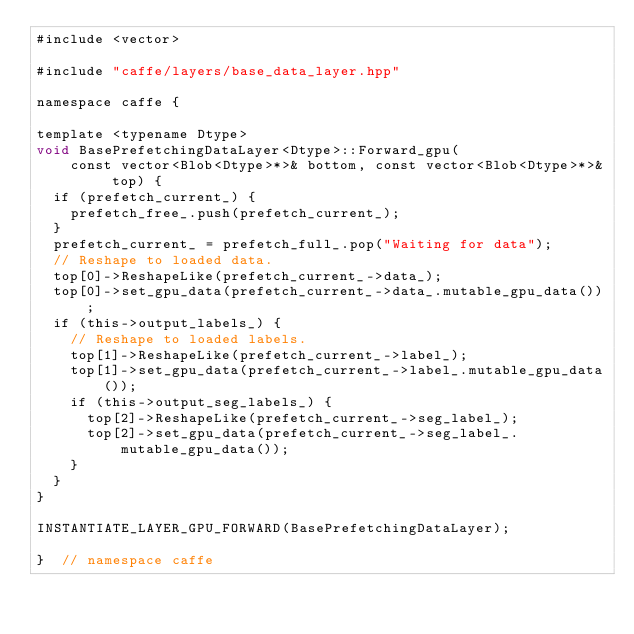<code> <loc_0><loc_0><loc_500><loc_500><_Cuda_>#include <vector>

#include "caffe/layers/base_data_layer.hpp"

namespace caffe {

template <typename Dtype>
void BasePrefetchingDataLayer<Dtype>::Forward_gpu(
    const vector<Blob<Dtype>*>& bottom, const vector<Blob<Dtype>*>& top) {
  if (prefetch_current_) {
    prefetch_free_.push(prefetch_current_);
  }
  prefetch_current_ = prefetch_full_.pop("Waiting for data");
  // Reshape to loaded data.
  top[0]->ReshapeLike(prefetch_current_->data_);
  top[0]->set_gpu_data(prefetch_current_->data_.mutable_gpu_data());
  if (this->output_labels_) {
    // Reshape to loaded labels.
    top[1]->ReshapeLike(prefetch_current_->label_);
    top[1]->set_gpu_data(prefetch_current_->label_.mutable_gpu_data());
    if (this->output_seg_labels_) {
      top[2]->ReshapeLike(prefetch_current_->seg_label_);
      top[2]->set_gpu_data(prefetch_current_->seg_label_.mutable_gpu_data());
    }
  }
}

INSTANTIATE_LAYER_GPU_FORWARD(BasePrefetchingDataLayer);

}  // namespace caffe
</code> 